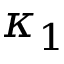Convert formula to latex. <formula><loc_0><loc_0><loc_500><loc_500>\kappa _ { 1 }</formula> 